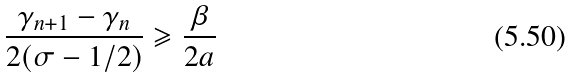Convert formula to latex. <formula><loc_0><loc_0><loc_500><loc_500>\frac { \gamma _ { n + 1 } - \gamma _ { n } } { 2 ( \sigma - 1 / 2 ) } \geqslant \frac { \beta } { 2 a }</formula> 